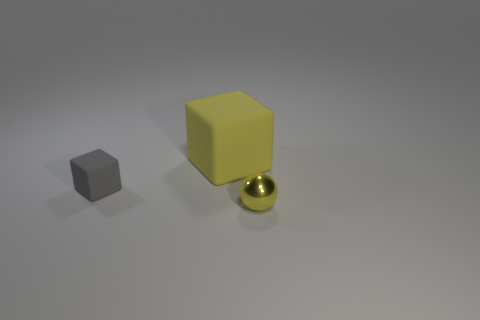There is a yellow thing in front of the tiny object on the left side of the matte block behind the small gray matte object; what is its material?
Your answer should be compact. Metal. How many other objects are the same color as the small matte cube?
Your answer should be compact. 0. How many gray things are either matte objects or big matte blocks?
Offer a very short reply. 1. What is the material of the object that is on the right side of the big yellow matte block?
Your response must be concise. Metal. Is the material of the yellow object in front of the big yellow cube the same as the large yellow block?
Offer a terse response. No. What shape is the small shiny thing?
Ensure brevity in your answer.  Sphere. How many small rubber objects are in front of the matte block left of the cube that is behind the gray matte thing?
Provide a succinct answer. 0. How many other things are there of the same material as the big yellow block?
Your response must be concise. 1. There is another object that is the same size as the gray object; what is its material?
Provide a short and direct response. Metal. There is a small object behind the yellow shiny ball; does it have the same color as the big rubber object on the right side of the gray thing?
Offer a very short reply. No. 